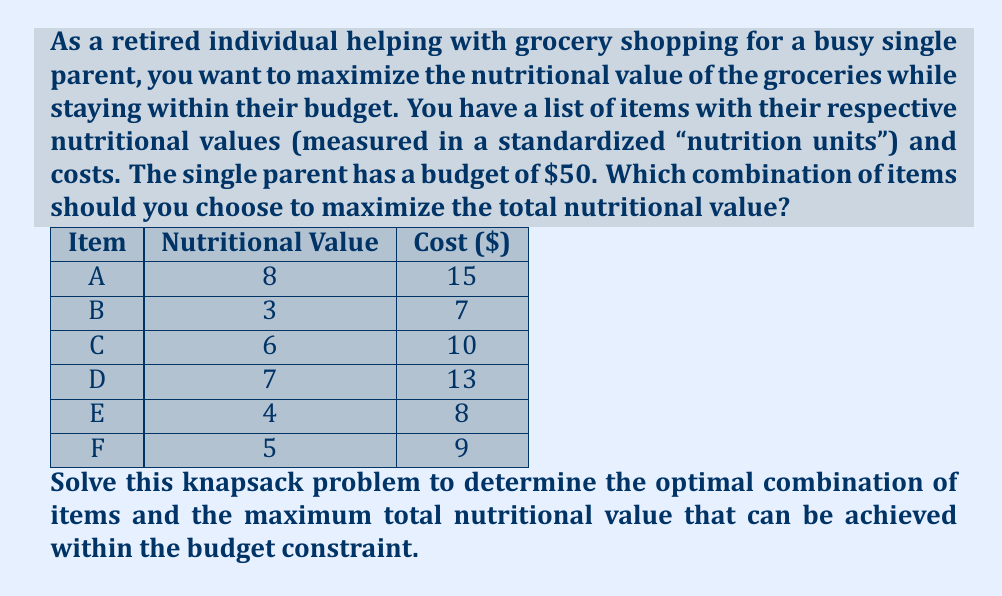Help me with this question. To solve this knapsack problem, we'll use dynamic programming. Let's define our approach:

1) Create a 2D array $dp[i][j]$ where $i$ represents the items (0 to 6) and $j$ represents the budget (0 to 50).

2) $dp[i][j]$ will store the maximum nutritional value that can be achieved with the first $i$ items and a budget of $j$.

3) We'll use the following recurrence relation:

   $$dp[i][j] = \max(dp[i-1][j], dp[i-1][j-cost[i]] + value[i])$$

   This means for each item, we have two choices:
   - Don't include the item: $dp[i-1][j]$
   - Include the item if we have enough budget: $dp[i-1][j-cost[i]] + value[i]$

4) We'll fill this table bottom-up.

5) After filling the table, $dp[6][50]$ will give us the maximum nutritional value.

6) To find which items were selected, we'll backtrack from $dp[6][50]$.

Let's fill the table (showing only the relevant part for brevity):

$$
\begin{array}{c|ccccccc}
 & 0 & \cdots & 7 & 8 & 9 & 10 & \cdots & 50 \\
\hline
0 & 0 & \cdots & 0 & 0 & 0 & 0 & \cdots & 0 \\
A & 0 & \cdots & 0 & 0 & 0 & 0 & \cdots & 8 \\
B & 0 & \cdots & 3 & 3 & 3 & 3 & \cdots & 11 \\
C & 0 & \cdots & 3 & 3 & 3 & 6 & \cdots & 14 \\
D & 0 & \cdots & 3 & 3 & 3 & 6 & \cdots & 15 \\
E & 0 & \cdots & 3 & 4 & 4 & 6 & \cdots & 18 \\
F & 0 & \cdots & 3 & 4 & 5 & 6 & \cdots & 19 \\
\end{array}
$$

The maximum nutritional value is 19, found at $dp[6][50]$.

To find which items were selected, we backtrack:
- Start at $dp[6][50] = 19$
- Compare with $dp[5][50] = 18$. Since they're different, item F was selected.
- Move to $dp[5][41] = 14$ (50 - 9 = 41)
- Compare with $dp[4][41] = 14$. They're the same, so E wasn't selected.
- Compare $dp[4][41] = 14$ with $dp[3][41] = 11$. They're different, so D was selected.
- Move to $dp[3][28] = 8$ (41 - 13 = 28)
- Compare with $dp[2][28] = 6$. They're different, so C was selected.
- Move to $dp[2][18] = 6$ (28 - 10 = 18)
- Compare with $dp[1][18] = 0$. They're different, so B was selected.
- Move to $dp[1][11] = 3$ (18 - 7 = 11)
- Compare with $dp[0][11] = 0$. They're different, so A was selected.

Therefore, the selected items are A, B, C, D, and F.
Answer: The optimal combination of items is A, B, C, D, and F, which provides a maximum total nutritional value of 19 units within the $50 budget. 